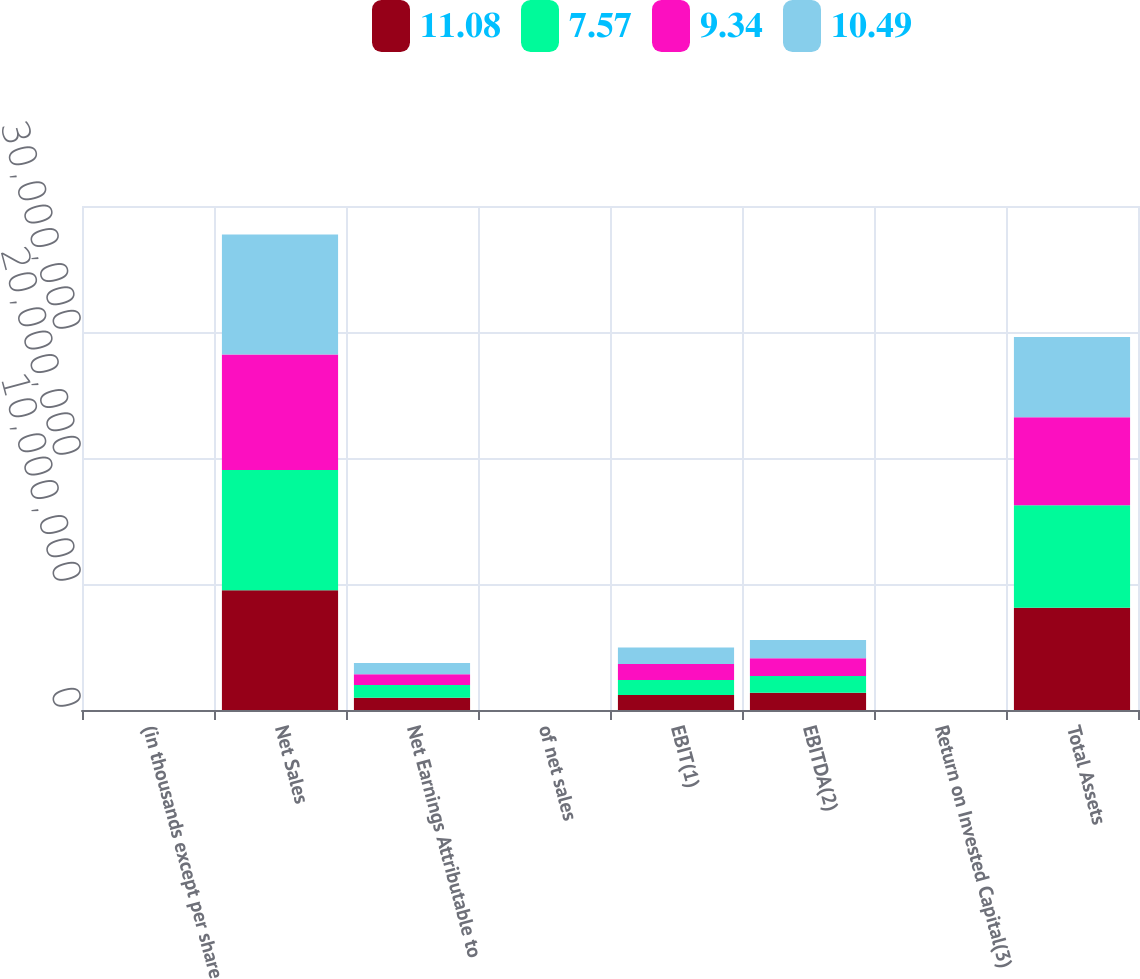Convert chart to OTSL. <chart><loc_0><loc_0><loc_500><loc_500><stacked_bar_chart><ecel><fcel>(in thousands except per share<fcel>Net Sales<fcel>Net Earnings Attributable to<fcel>of net sales<fcel>EBIT(1)<fcel>EBITDA(2)<fcel>Return on Invested Capital(3)<fcel>Total Assets<nl><fcel>11.08<fcel>2019<fcel>9.49732e+06<fcel>978806<fcel>10.31<fcel>1.19592e+06<fcel>1.36113e+06<fcel>15.63<fcel>8.109e+06<nl><fcel>7.57<fcel>2018<fcel>9.5457e+06<fcel>1.01214e+06<fcel>10.6<fcel>1.17952e+06<fcel>1.34138e+06<fcel>16.24<fcel>8.14229e+06<nl><fcel>9.34<fcel>2017<fcel>9.16752e+06<fcel>846735<fcel>9.24<fcel>1.27637e+06<fcel>1.40735e+06<fcel>16.3<fcel>6.97591e+06<nl><fcel>10.49<fcel>2016<fcel>9.52322e+06<fcel>890052<fcel>9.35<fcel>1.31292e+06<fcel>1.44489e+06<fcel>18.89<fcel>6.37007e+06<nl></chart> 